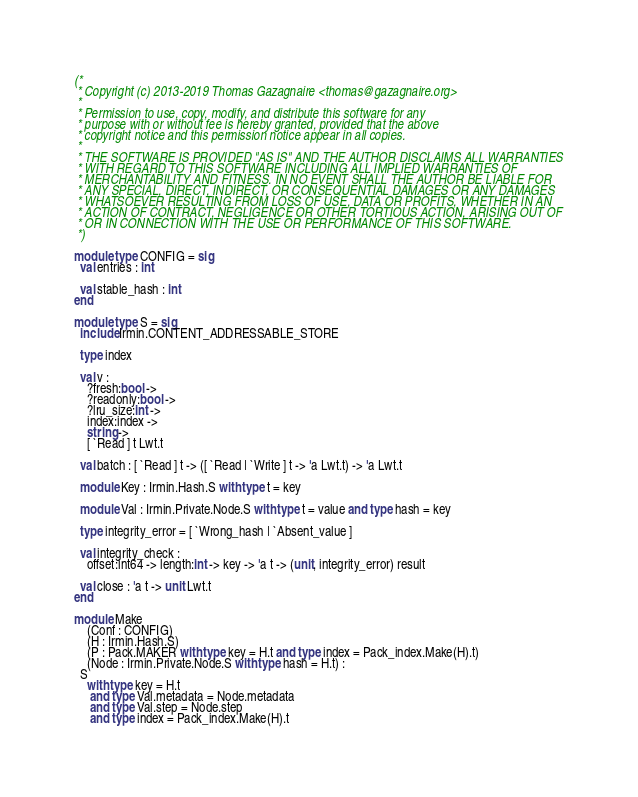Convert code to text. <code><loc_0><loc_0><loc_500><loc_500><_OCaml_>(*
 * Copyright (c) 2013-2019 Thomas Gazagnaire <thomas@gazagnaire.org>
 *
 * Permission to use, copy, modify, and distribute this software for any
 * purpose with or without fee is hereby granted, provided that the above
 * copyright notice and this permission notice appear in all copies.
 *
 * THE SOFTWARE IS PROVIDED "AS IS" AND THE AUTHOR DISCLAIMS ALL WARRANTIES
 * WITH REGARD TO THIS SOFTWARE INCLUDING ALL IMPLIED WARRANTIES OF
 * MERCHANTABILITY AND FITNESS. IN NO EVENT SHALL THE AUTHOR BE LIABLE FOR
 * ANY SPECIAL, DIRECT, INDIRECT, OR CONSEQUENTIAL DAMAGES OR ANY DAMAGES
 * WHATSOEVER RESULTING FROM LOSS OF USE, DATA OR PROFITS, WHETHER IN AN
 * ACTION OF CONTRACT, NEGLIGENCE OR OTHER TORTIOUS ACTION, ARISING OUT OF
 * OR IN CONNECTION WITH THE USE OR PERFORMANCE OF THIS SOFTWARE.
 *)

module type CONFIG = sig
  val entries : int

  val stable_hash : int
end

module type S = sig
  include Irmin.CONTENT_ADDRESSABLE_STORE

  type index

  val v :
    ?fresh:bool ->
    ?readonly:bool ->
    ?lru_size:int ->
    index:index ->
    string ->
    [ `Read ] t Lwt.t

  val batch : [ `Read ] t -> ([ `Read | `Write ] t -> 'a Lwt.t) -> 'a Lwt.t

  module Key : Irmin.Hash.S with type t = key

  module Val : Irmin.Private.Node.S with type t = value and type hash = key

  type integrity_error = [ `Wrong_hash | `Absent_value ]

  val integrity_check :
    offset:int64 -> length:int -> key -> 'a t -> (unit, integrity_error) result

  val close : 'a t -> unit Lwt.t
end

module Make
    (Conf : CONFIG)
    (H : Irmin.Hash.S)
    (P : Pack.MAKER with type key = H.t and type index = Pack_index.Make(H).t)
    (Node : Irmin.Private.Node.S with type hash = H.t) :
  S
    with type key = H.t
     and type Val.metadata = Node.metadata
     and type Val.step = Node.step
     and type index = Pack_index.Make(H).t
</code> 